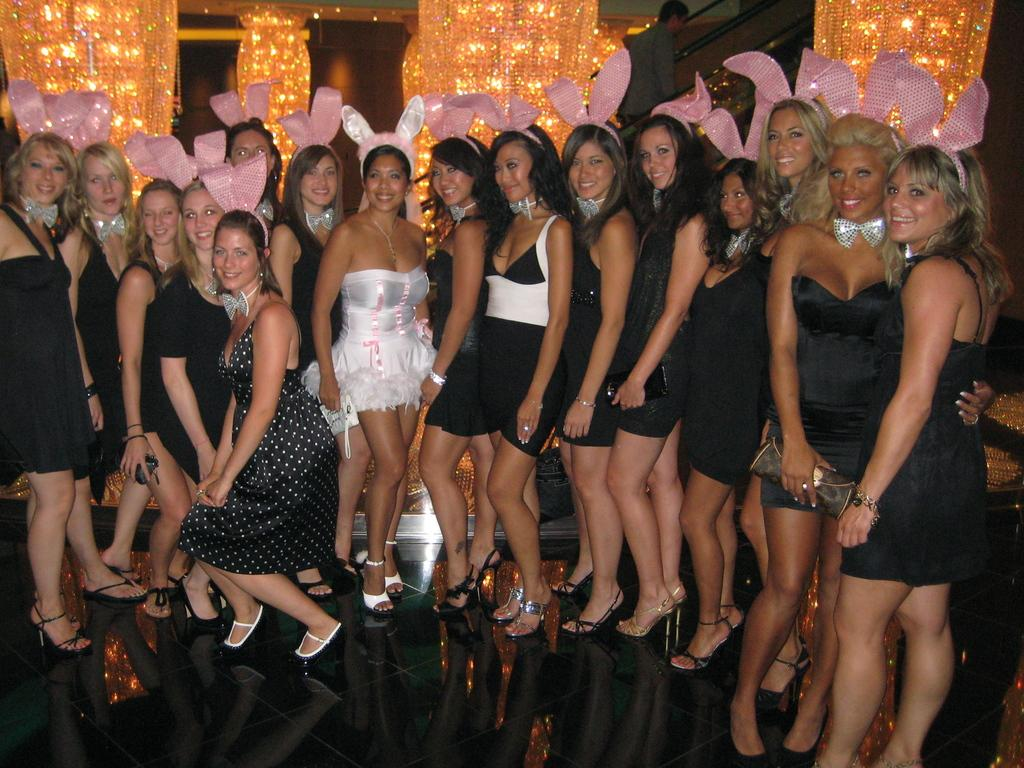What is the main subject of the image? The main subject of the image is a crowd of women. Where are the women located in the image? The women are standing on a stage in the image. What is the facial expression of the women? The women are smiling in the image. What are the women doing in the image? The women are giving a pose for the picture. What can be seen in the background of the image? There are lights in the background of the image. What type of joke is the parent telling the crowd of women in the image? There is no parent or joke present in the image; it features a crowd of women standing on a stage and giving a pose for the picture. 